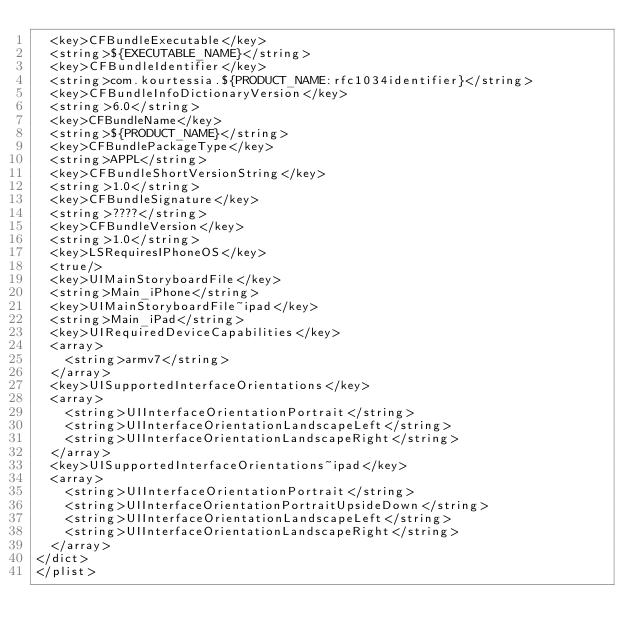Convert code to text. <code><loc_0><loc_0><loc_500><loc_500><_XML_>	<key>CFBundleExecutable</key>
	<string>${EXECUTABLE_NAME}</string>
	<key>CFBundleIdentifier</key>
	<string>com.kourtessia.${PRODUCT_NAME:rfc1034identifier}</string>
	<key>CFBundleInfoDictionaryVersion</key>
	<string>6.0</string>
	<key>CFBundleName</key>
	<string>${PRODUCT_NAME}</string>
	<key>CFBundlePackageType</key>
	<string>APPL</string>
	<key>CFBundleShortVersionString</key>
	<string>1.0</string>
	<key>CFBundleSignature</key>
	<string>????</string>
	<key>CFBundleVersion</key>
	<string>1.0</string>
	<key>LSRequiresIPhoneOS</key>
	<true/>
	<key>UIMainStoryboardFile</key>
	<string>Main_iPhone</string>
	<key>UIMainStoryboardFile~ipad</key>
	<string>Main_iPad</string>
	<key>UIRequiredDeviceCapabilities</key>
	<array>
		<string>armv7</string>
	</array>
	<key>UISupportedInterfaceOrientations</key>
	<array>
		<string>UIInterfaceOrientationPortrait</string>
		<string>UIInterfaceOrientationLandscapeLeft</string>
		<string>UIInterfaceOrientationLandscapeRight</string>
	</array>
	<key>UISupportedInterfaceOrientations~ipad</key>
	<array>
		<string>UIInterfaceOrientationPortrait</string>
		<string>UIInterfaceOrientationPortraitUpsideDown</string>
		<string>UIInterfaceOrientationLandscapeLeft</string>
		<string>UIInterfaceOrientationLandscapeRight</string>
	</array>
</dict>
</plist>
</code> 